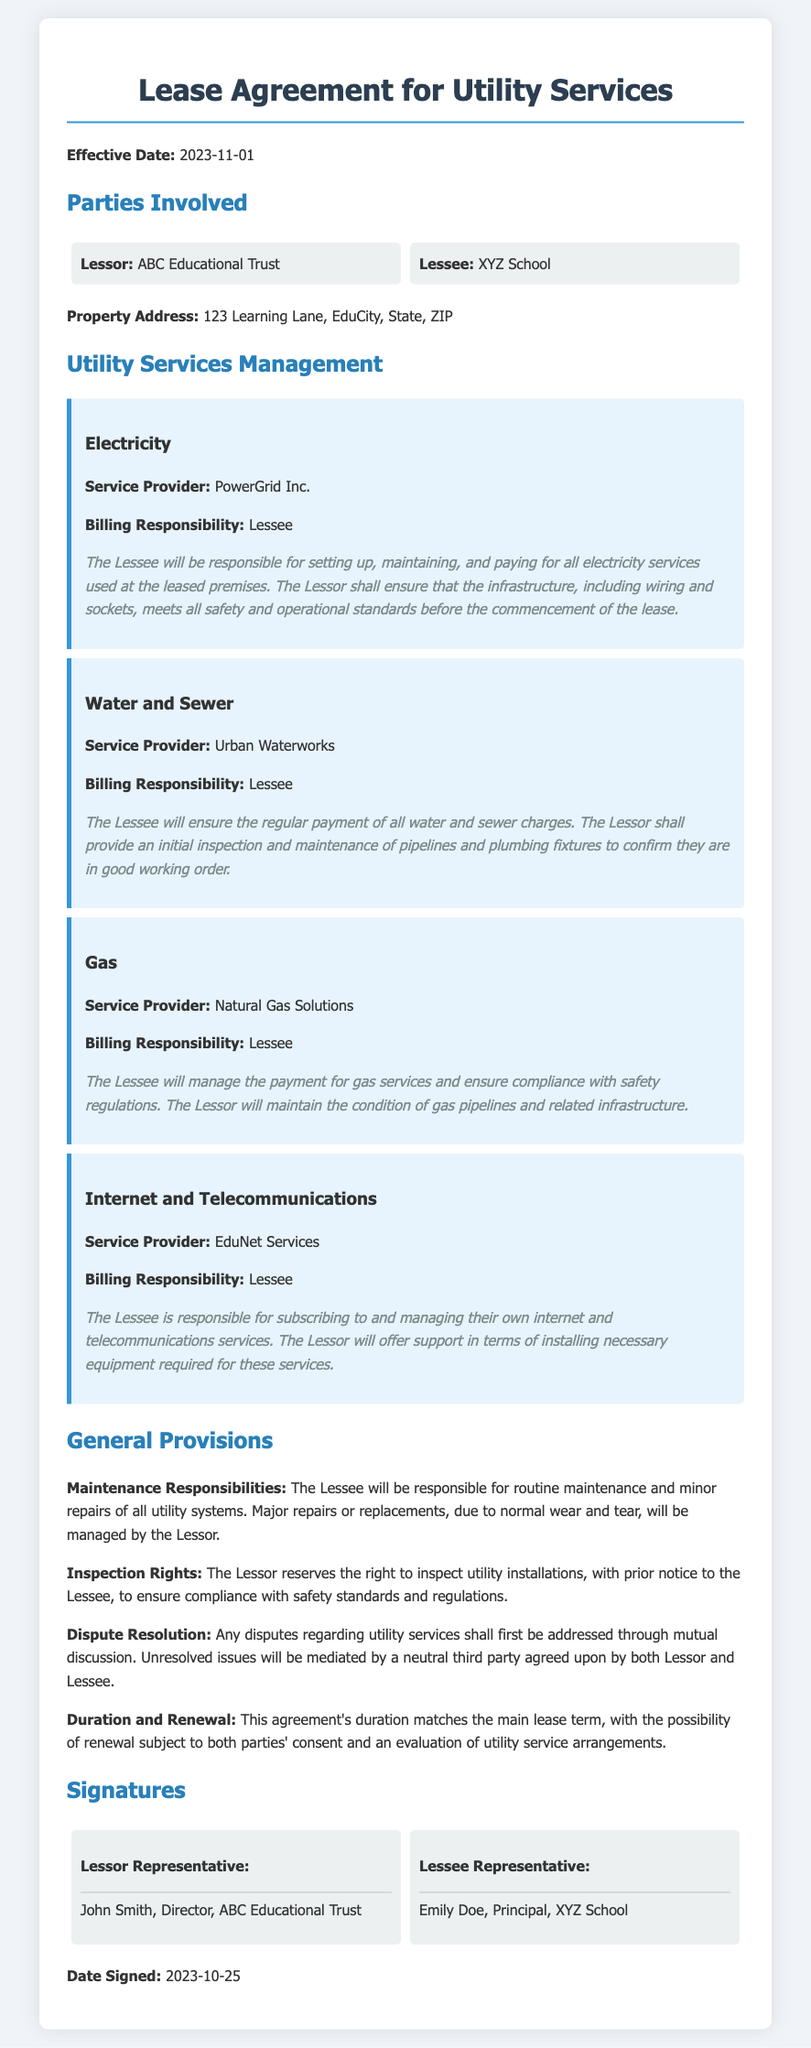what is the effective date of the lease agreement? The effective date is provided in the document and specifies when the lease agreement starts.
Answer: 2023-11-01 who is the lessor in this agreement? The lessor is the party that owns the property and is leasing it out. This is stated clearly in the document.
Answer: ABC Educational Trust who is responsible for the electricity billing? The document indicates which party is charged with the billing responsibility for electricity services.
Answer: Lessee what service provider is mentioned for Internet and Telecommunications? The document names the service provider responsible for these utility services, which is relevant for connectivity at the premises.
Answer: EduNet Services what is the duration of this lease agreement? The lease agreement's duration is related to the main lease term as stated in the general provisions section.
Answer: Matches the main lease term what are the lessee's responsibilities regarding utility services management? The document outlines the specific roles and tasks assigned to the lessee concerning utility services management.
Answer: Setting up, maintaining, and paying for utilities what is the dispute resolution mechanism mentioned in the agreement? The document specifies how disputes shall be handled between the lessor and lessee concerning utility services.
Answer: Mutual discussion followed by mediation who signed as the lessee representative? The section on signatures clearly indicates who represented the lessee in the signing of the agreement.
Answer: Emily Doe, Principal, XYZ School 